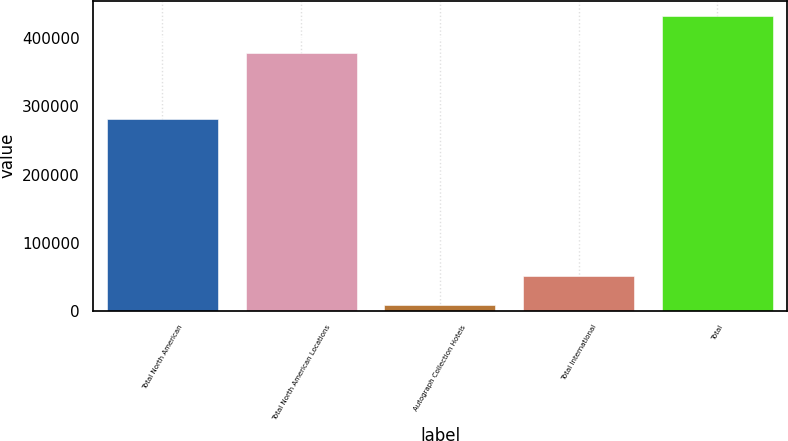Convert chart to OTSL. <chart><loc_0><loc_0><loc_500><loc_500><bar_chart><fcel>Total North American<fcel>Total North American Locations<fcel>Autograph Collection Hotels<fcel>Total International<fcel>Total<nl><fcel>281908<fcel>378174<fcel>8741<fcel>51203.8<fcel>433369<nl></chart> 